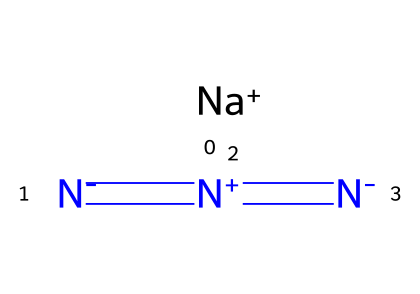How many nitrogen atoms are in sodium azide? The SMILES representation shows three nitrogen atoms connected to one another, identified by the 'N' characters.
Answer: three What is the charge of the sodium ion in sodium azide? In the SMILES representation, the '[Na+]' indicates that sodium has a positive charge.
Answer: positive What functional group is present in sodium azide? The structure contains the azide group, denoted by the sequence '[N-]=[N+]=[N-]', which is characteristic of azides.
Answer: azide group How many total bonds does the azide group have? The azide group consists of three nitrogen atoms bonded twice (N=N) and a single bond between the first and second nitrogen, totaling three bonds.
Answer: three What type of reaction is sodium azide typically involved in during airbag deployment? Sodium azide decomposes rapidly to produce nitrogen gas when heated, which is a rapid exothermic reaction essential for airbag inflation.
Answer: decomposition Which nitrogen atom carries a positive charge in the azide structure? In the SMILES representation, the nitrogen with the '+' sign is located between two nitrogen atoms; this indicates it carries the positive charge.
Answer: middle nitrogen 